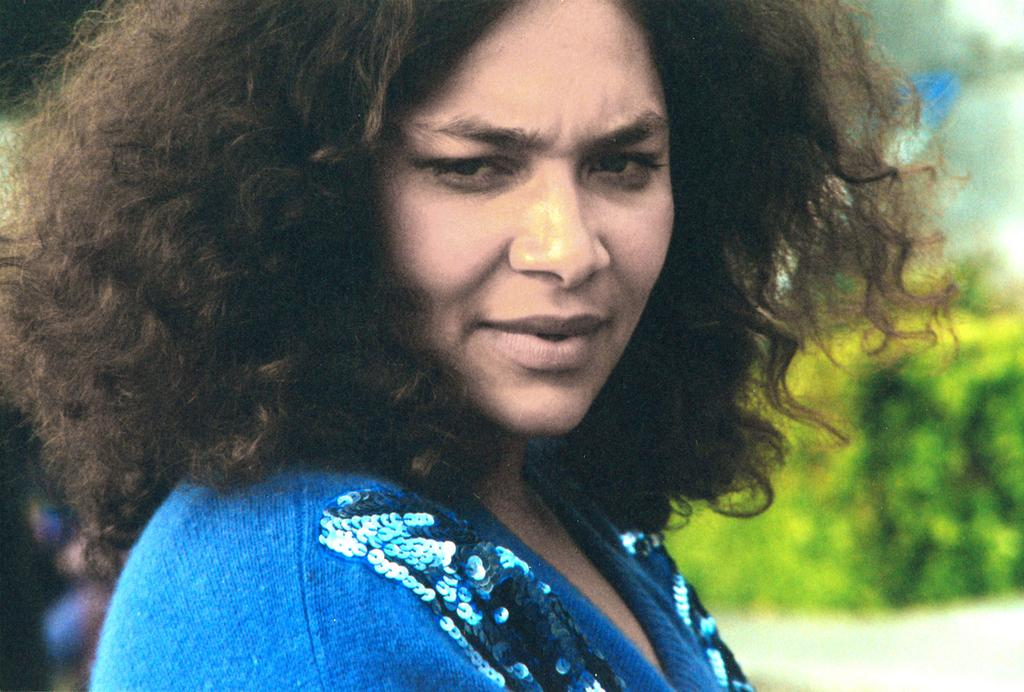Who is the main subject in the image? There is a woman in the image. What is the woman wearing? The woman is wearing a blue dress. Can you describe the background of the image? The background of the image is blurry. How many children are playing with the grandmother in the image? There are no children or grandmother present in the image; it only features a woman wearing a blue dress. What type of base is supporting the woman in the image? There is no base visible in the image; the woman is standing on the ground. 